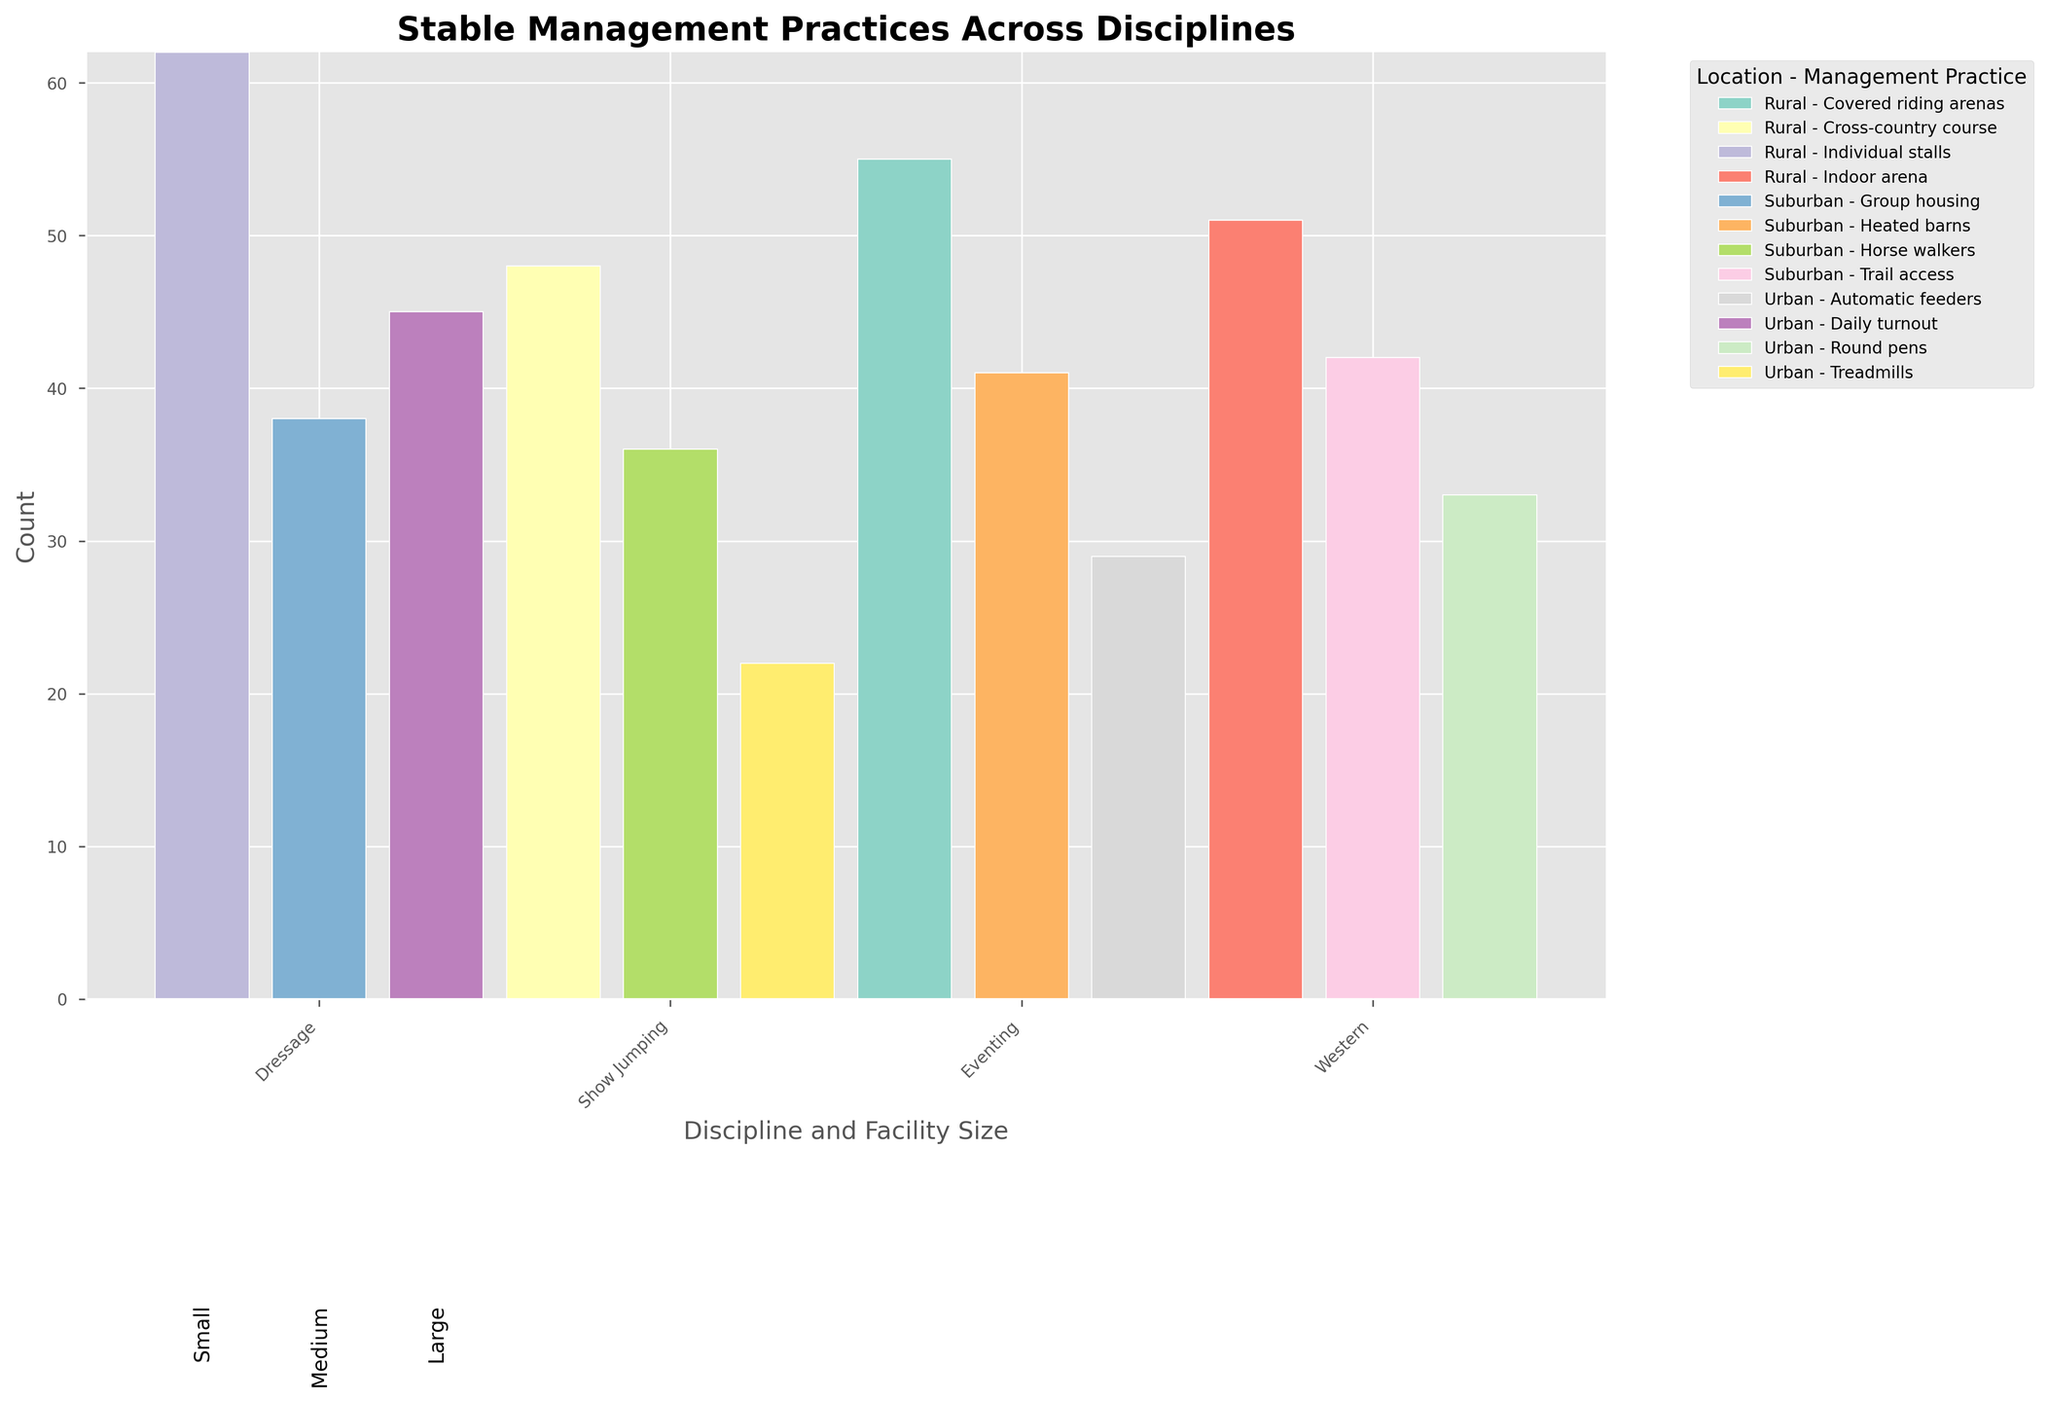What is the title of the figure? The title is located at the top of the figure and is usually larger and bolder than other text.
Answer: Stable Management Practices Across Disciplines Which discipline and facility size combination has the highest count for Individual stalls? Look across the bars to find the combination labeled 'Individual stalls' with the highest bar height.
Answer: Dressage, Large How many total management practices are listed for Urban locations? Count all the different management practices associated with Urban locations across all disciplines.
Answer: 4 Which facility size in Suburban locations has the highest count for Horse walkers in Eventing discipline? Identify the bars corresponding to Horse walkers under the Eventing discipline and Suburban location, and find the one with the highest height.
Answer: Medium What is the combined count for Covered riding arenas and Heated barns in Show Jumping? Add the counts of Covered riding arenas and Heated barns under Show Jumping across all facility sizes and locations.
Answer: 55 (Covered riding arenas) + 41 (Heated barns) = 96 What discipline has the lowest total count across all facility sizes and locations? Sum the counts of all management practices for each discipline and compare to find the lowest.
Answer: Eventing Which discipline and facility size combination uses Treadmills in Urban locations, and what is the count? Look for the bar labeled 'Treadmills' under Urban locations, and identify the corresponding discipline and facility size combination.
Answer: Eventing, Small, 22 Are Automatic feeders more commonly used in Urban or Suburban locations for Show Jumping? Compare the count of Automatic feeders used in Urban locations with those in Suburban locations for Show Jumping.
Answer: Urban How does the count of Daily turnout in Dressage compare with Round pens in Western in Urban locations? Identify and compare the heights of the bars for Daily turnout in Dressage and Round pens in Western, both in Urban locations.
Answer: Daily turnout (45) is higher than Round pens (33) 